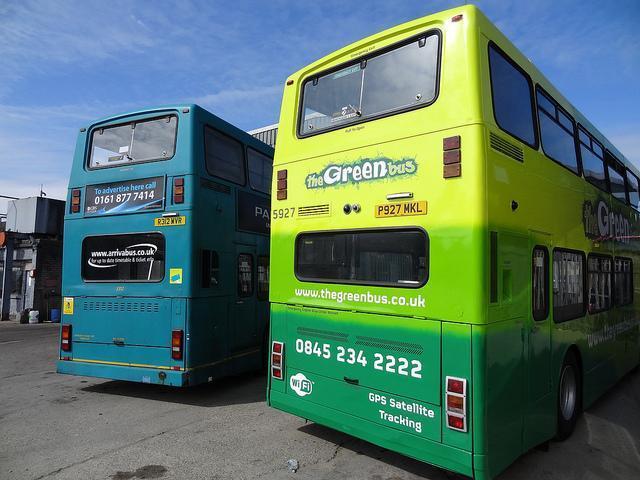How many buses are there?
Give a very brief answer. 2. How many apples are there?
Give a very brief answer. 0. 